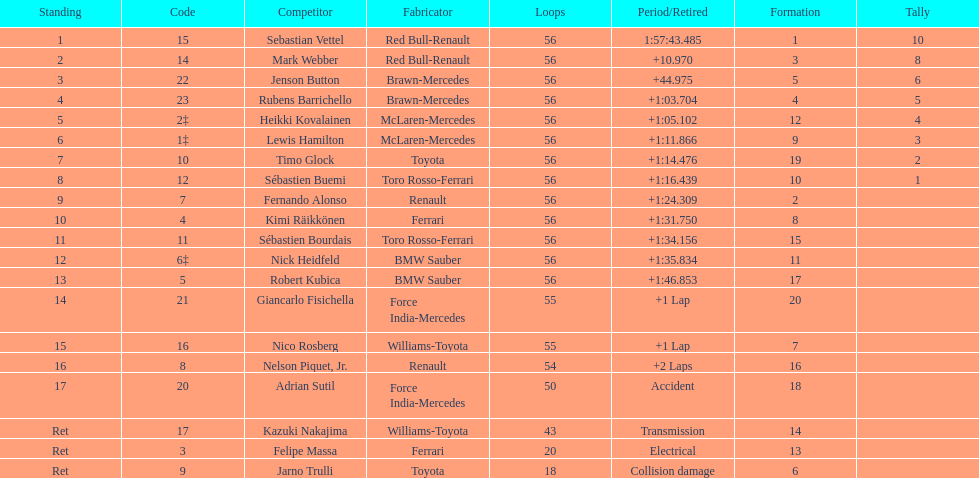What is the name of a driver that ferrari was not a constructor for? Sebastian Vettel. 